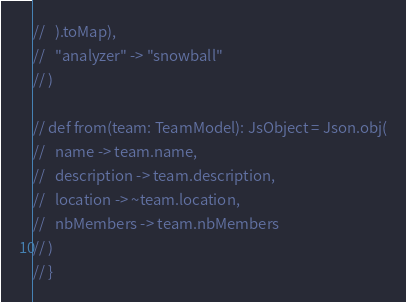Convert code to text. <code><loc_0><loc_0><loc_500><loc_500><_Scala_>//   ).toMap),
//   "analyzer" -> "snowball"
// )

// def from(team: TeamModel): JsObject = Json.obj(
//   name -> team.name,
//   description -> team.description,
//   location -> ~team.location,
//   nbMembers -> team.nbMembers
// )
// }
</code> 